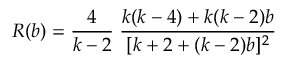Convert formula to latex. <formula><loc_0><loc_0><loc_500><loc_500>R ( b ) = \frac { 4 } { k - 2 } \, \frac { k ( k - 4 ) + k ( k - 2 ) b } { [ k + 2 + ( k - 2 ) b ] ^ { 2 } }</formula> 